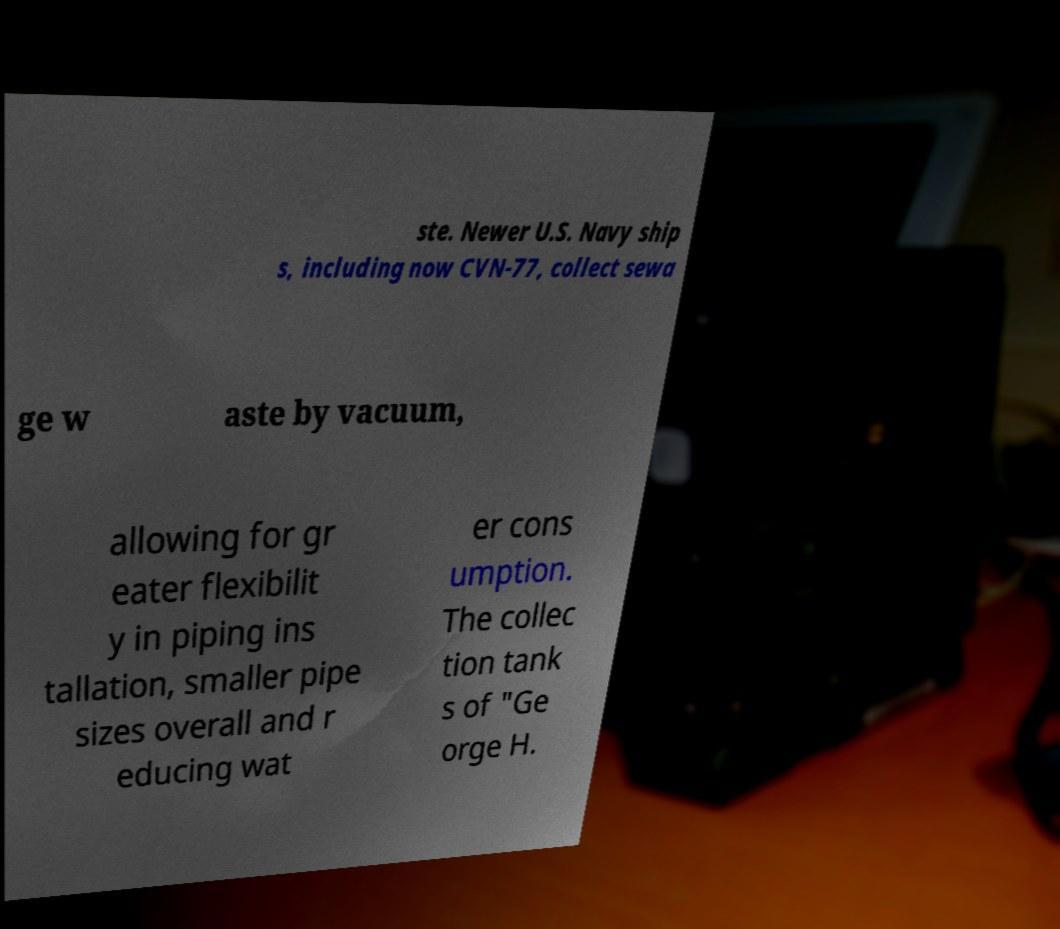Can you accurately transcribe the text from the provided image for me? ste. Newer U.S. Navy ship s, including now CVN-77, collect sewa ge w aste by vacuum, allowing for gr eater flexibilit y in piping ins tallation, smaller pipe sizes overall and r educing wat er cons umption. The collec tion tank s of "Ge orge H. 